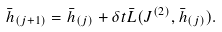Convert formula to latex. <formula><loc_0><loc_0><loc_500><loc_500>\bar { h } _ { ( j + 1 ) } = \bar { h } _ { ( j ) } + \delta t \bar { L } ( J ^ { ( 2 ) } , \bar { h } _ { ( j ) } ) .</formula> 